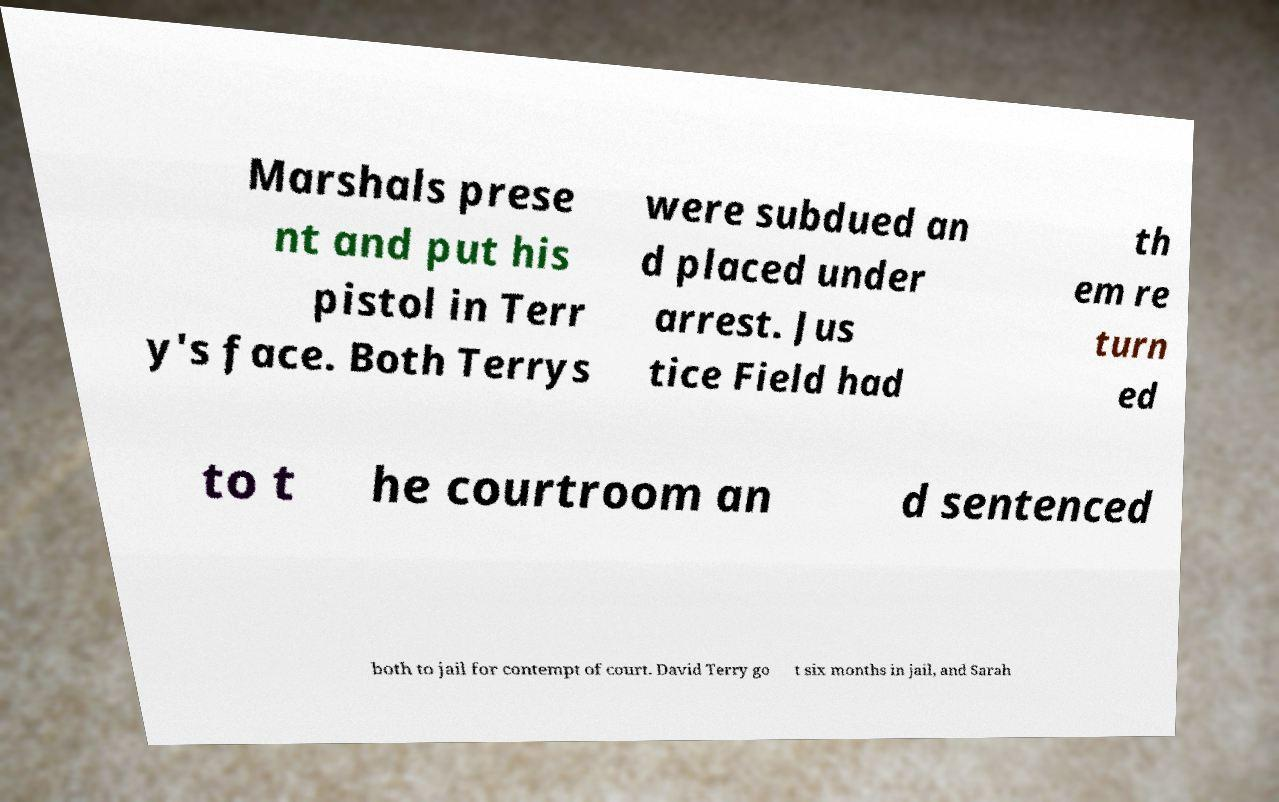Could you assist in decoding the text presented in this image and type it out clearly? Marshals prese nt and put his pistol in Terr y's face. Both Terrys were subdued an d placed under arrest. Jus tice Field had th em re turn ed to t he courtroom an d sentenced both to jail for contempt of court. David Terry go t six months in jail, and Sarah 